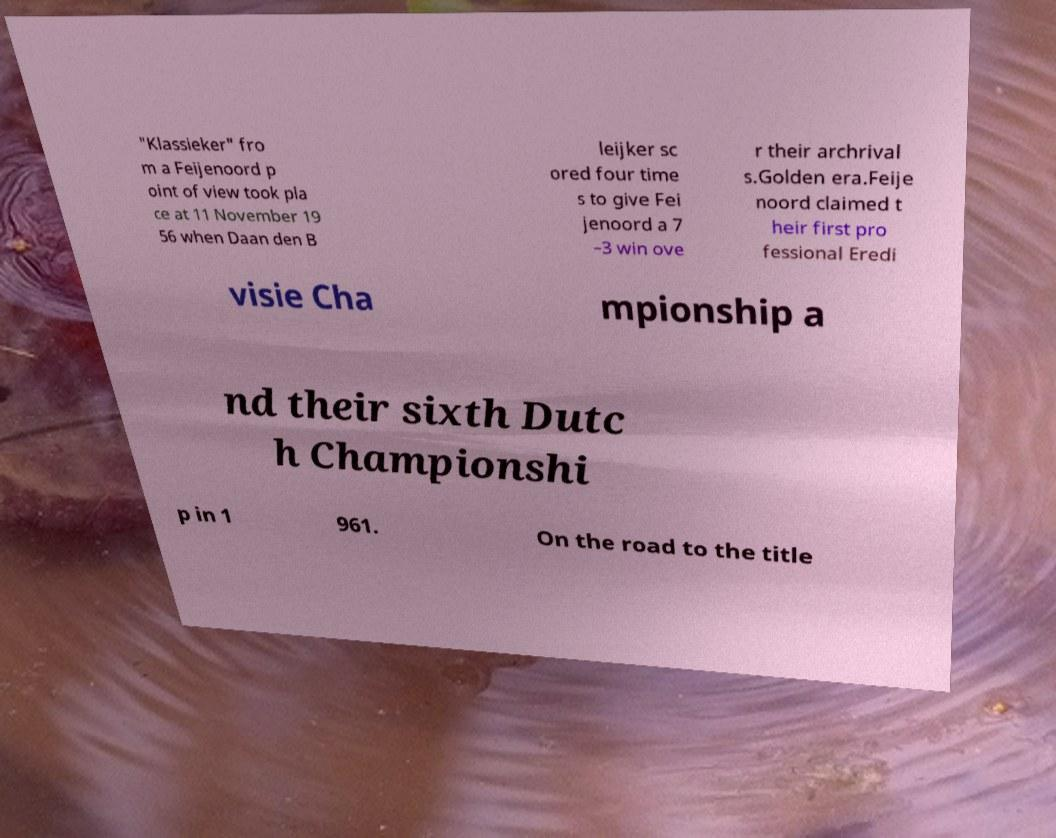For documentation purposes, I need the text within this image transcribed. Could you provide that? "Klassieker" fro m a Feijenoord p oint of view took pla ce at 11 November 19 56 when Daan den B leijker sc ored four time s to give Fei jenoord a 7 –3 win ove r their archrival s.Golden era.Feije noord claimed t heir first pro fessional Eredi visie Cha mpionship a nd their sixth Dutc h Championshi p in 1 961. On the road to the title 